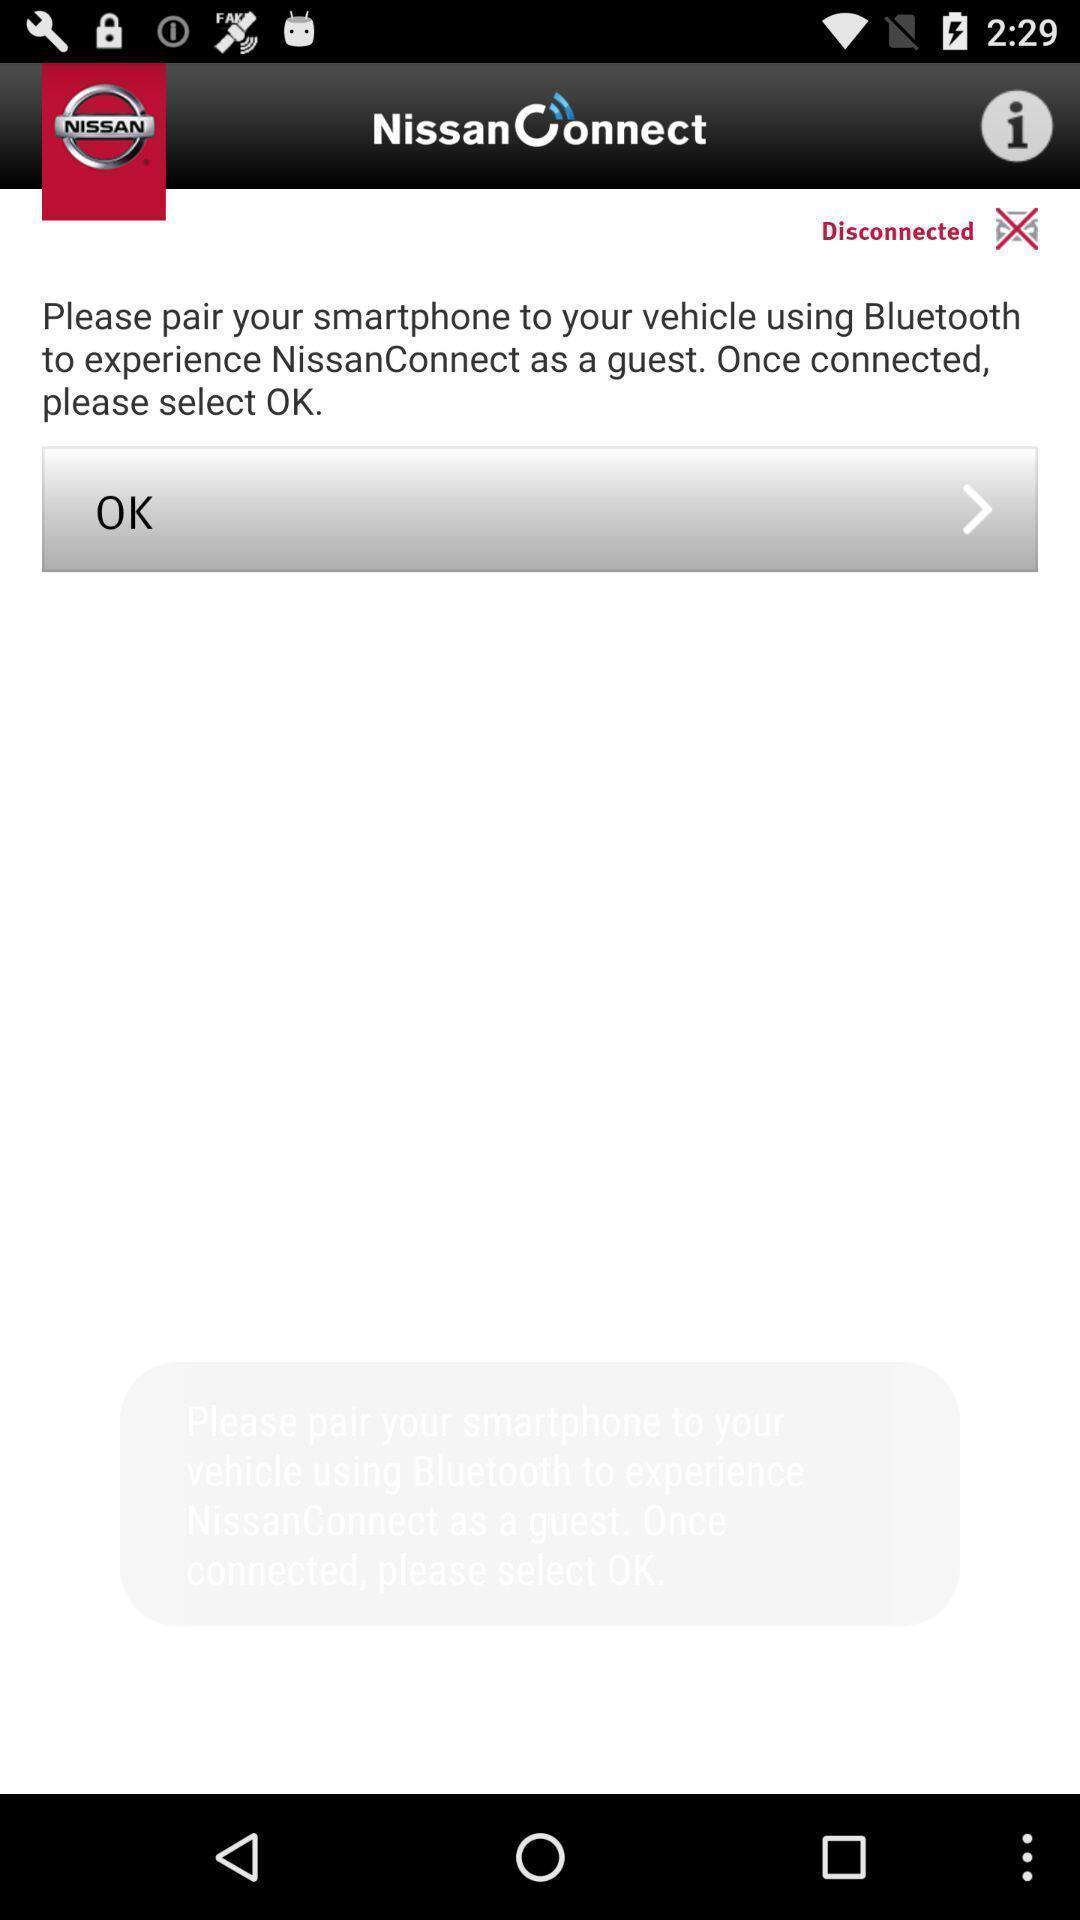Please provide a description for this image. Page displayed pair a device via bluetooth. 